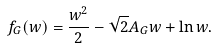Convert formula to latex. <formula><loc_0><loc_0><loc_500><loc_500>f _ { G } ( w ) = \frac { w ^ { 2 } } { 2 } - \sqrt { 2 } A _ { G } w + \ln w .</formula> 